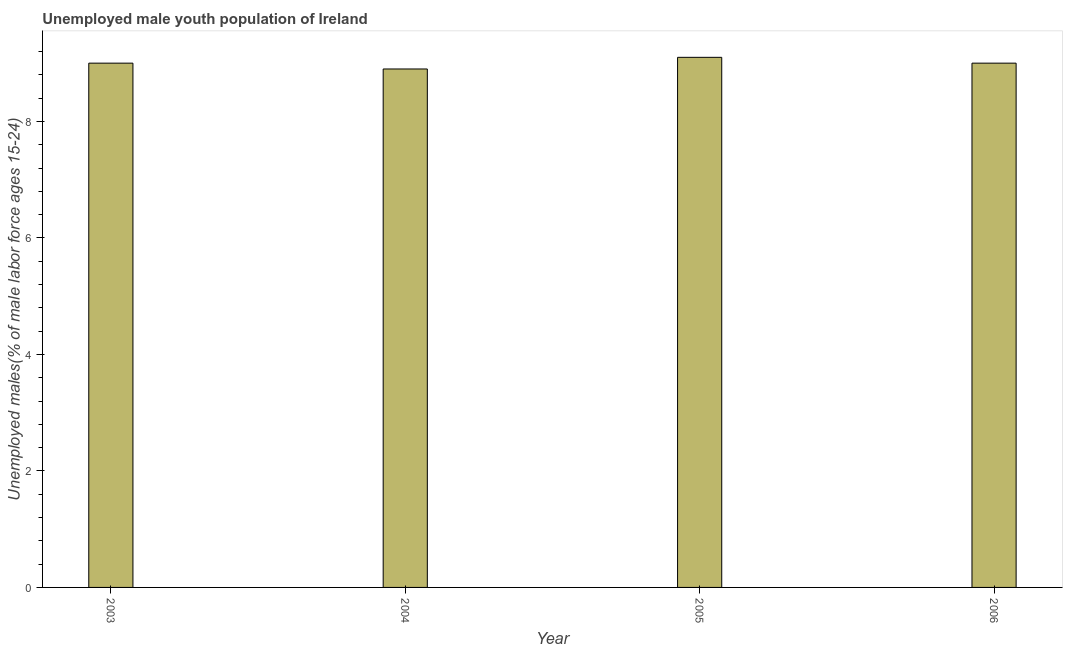Does the graph contain any zero values?
Keep it short and to the point. No. What is the title of the graph?
Ensure brevity in your answer.  Unemployed male youth population of Ireland. What is the label or title of the X-axis?
Your answer should be compact. Year. What is the label or title of the Y-axis?
Your response must be concise. Unemployed males(% of male labor force ages 15-24). Across all years, what is the maximum unemployed male youth?
Ensure brevity in your answer.  9.1. Across all years, what is the minimum unemployed male youth?
Provide a short and direct response. 8.9. In which year was the unemployed male youth maximum?
Keep it short and to the point. 2005. In which year was the unemployed male youth minimum?
Your response must be concise. 2004. What is the difference between the unemployed male youth in 2005 and 2006?
Your response must be concise. 0.1. What is the average unemployed male youth per year?
Keep it short and to the point. 9. Is the difference between the unemployed male youth in 2004 and 2006 greater than the difference between any two years?
Your response must be concise. No. Is the sum of the unemployed male youth in 2004 and 2006 greater than the maximum unemployed male youth across all years?
Your answer should be very brief. Yes. How many bars are there?
Make the answer very short. 4. How many years are there in the graph?
Keep it short and to the point. 4. What is the difference between two consecutive major ticks on the Y-axis?
Provide a succinct answer. 2. Are the values on the major ticks of Y-axis written in scientific E-notation?
Provide a succinct answer. No. What is the Unemployed males(% of male labor force ages 15-24) of 2004?
Your answer should be very brief. 8.9. What is the Unemployed males(% of male labor force ages 15-24) in 2005?
Your answer should be very brief. 9.1. What is the difference between the Unemployed males(% of male labor force ages 15-24) in 2003 and 2004?
Ensure brevity in your answer.  0.1. What is the difference between the Unemployed males(% of male labor force ages 15-24) in 2004 and 2005?
Keep it short and to the point. -0.2. What is the ratio of the Unemployed males(% of male labor force ages 15-24) in 2003 to that in 2004?
Give a very brief answer. 1.01. What is the ratio of the Unemployed males(% of male labor force ages 15-24) in 2003 to that in 2006?
Give a very brief answer. 1. 